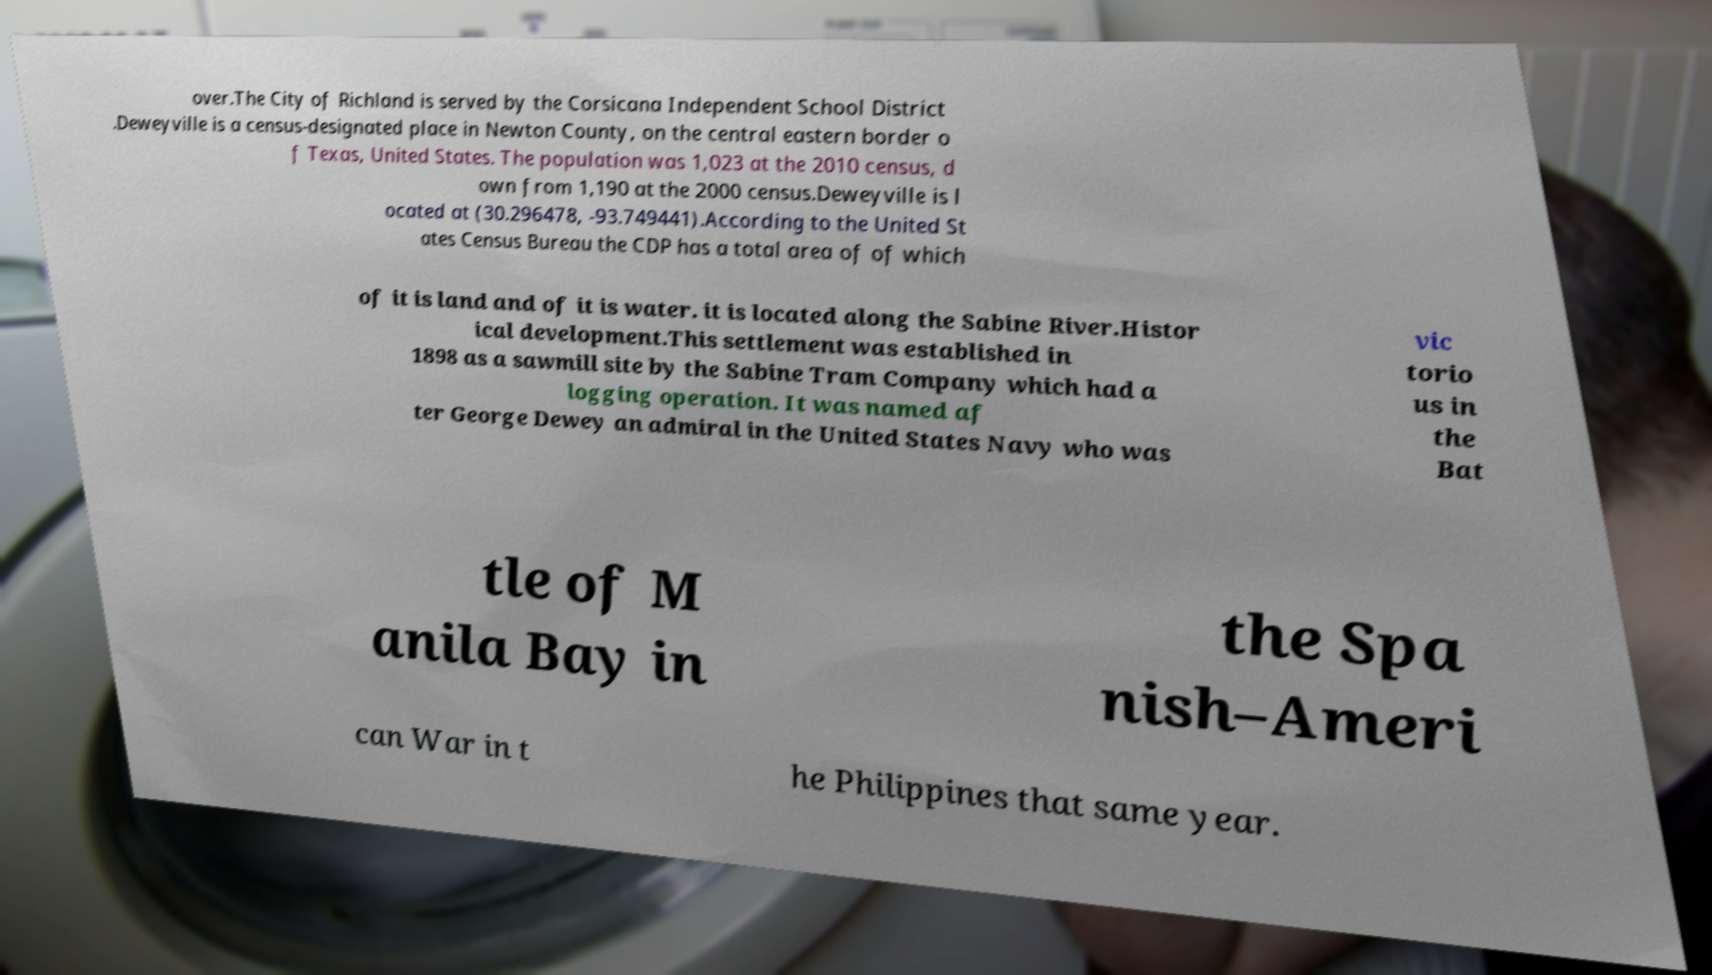Please read and relay the text visible in this image. What does it say? over.The City of Richland is served by the Corsicana Independent School District .Deweyville is a census-designated place in Newton County, on the central eastern border o f Texas, United States. The population was 1,023 at the 2010 census, d own from 1,190 at the 2000 census.Deweyville is l ocated at (30.296478, -93.749441).According to the United St ates Census Bureau the CDP has a total area of of which of it is land and of it is water. it is located along the Sabine River.Histor ical development.This settlement was established in 1898 as a sawmill site by the Sabine Tram Company which had a logging operation. It was named af ter George Dewey an admiral in the United States Navy who was vic torio us in the Bat tle of M anila Bay in the Spa nish–Ameri can War in t he Philippines that same year. 